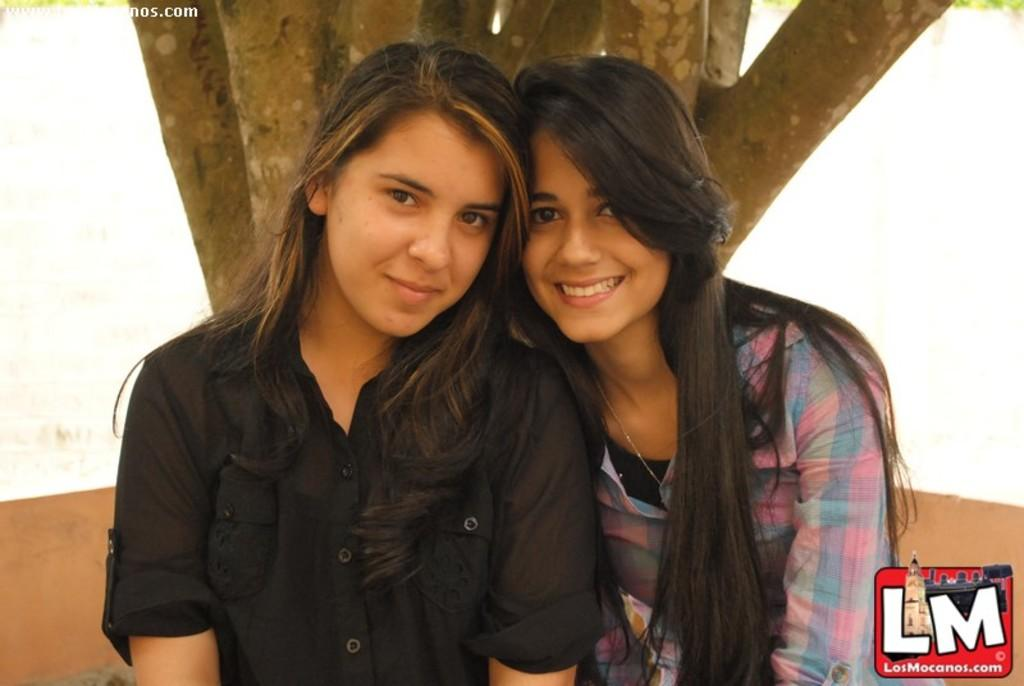How many people are in the image? There are two women in the image. What is one of the women wearing? One of the women is wearing a black dress. What can be seen in the background of the image? There is a tree in the background of the image. Can you see the women kissing in the image? There is no indication of the women kissing in the image. Is there a house visible in the image? There is no house present in the image; only a tree can be seen in the background. 